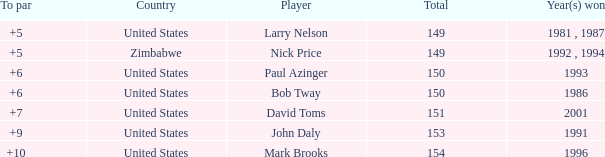What is the total for 1986 with a to par higher than 6? 0.0. 